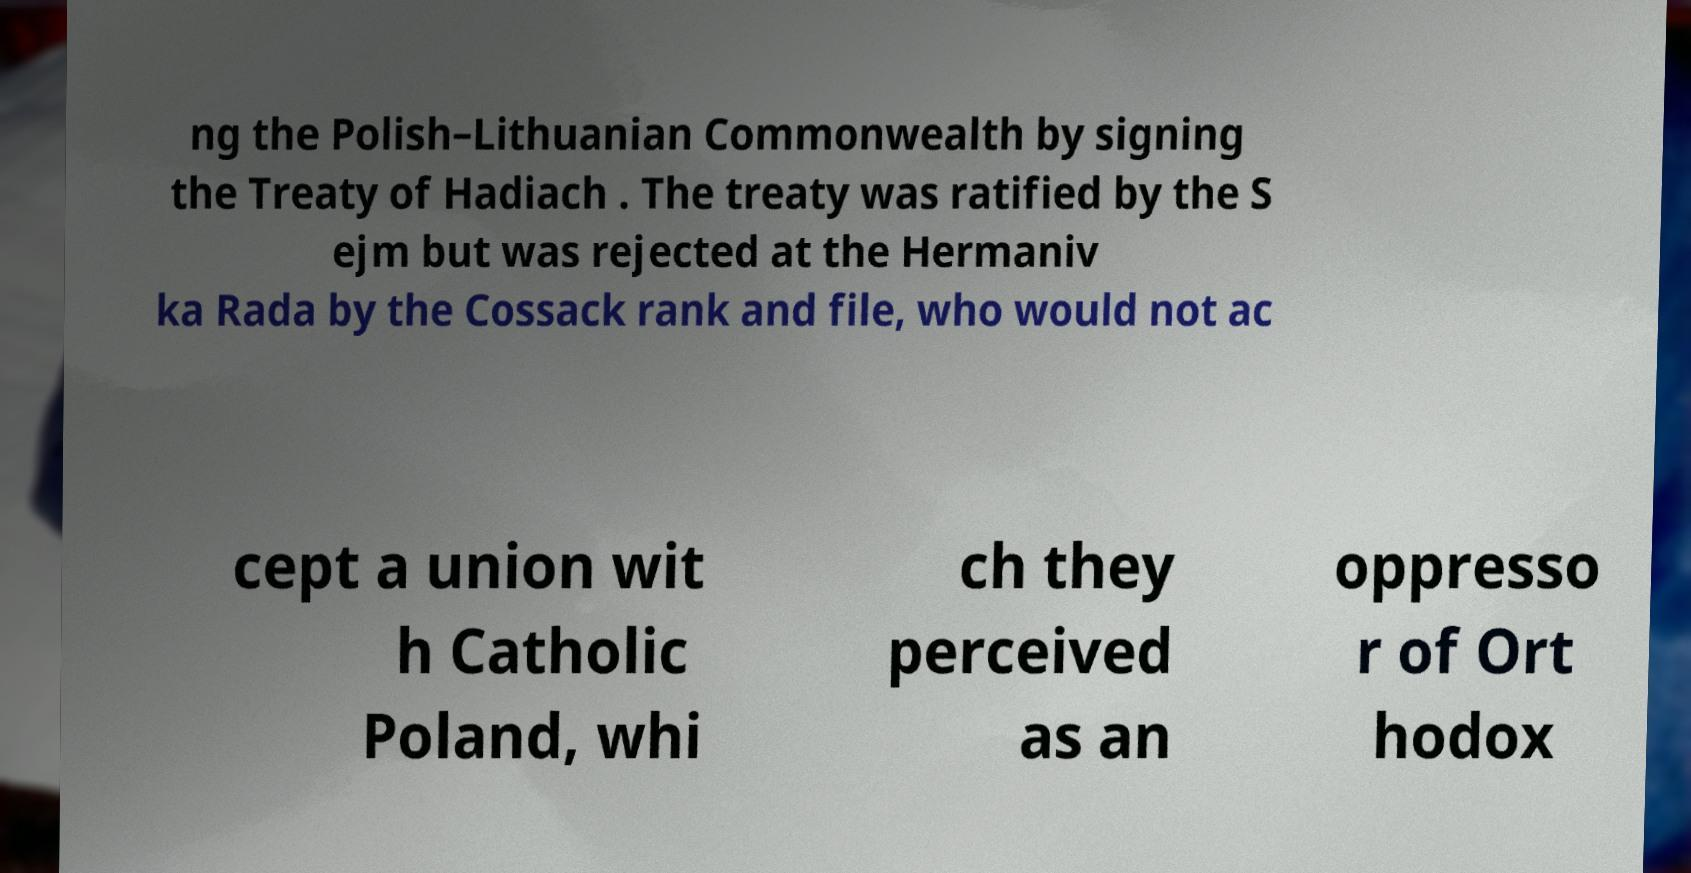Can you read and provide the text displayed in the image?This photo seems to have some interesting text. Can you extract and type it out for me? ng the Polish–Lithuanian Commonwealth by signing the Treaty of Hadiach . The treaty was ratified by the S ejm but was rejected at the Hermaniv ka Rada by the Cossack rank and file, who would not ac cept a union wit h Catholic Poland, whi ch they perceived as an oppresso r of Ort hodox 